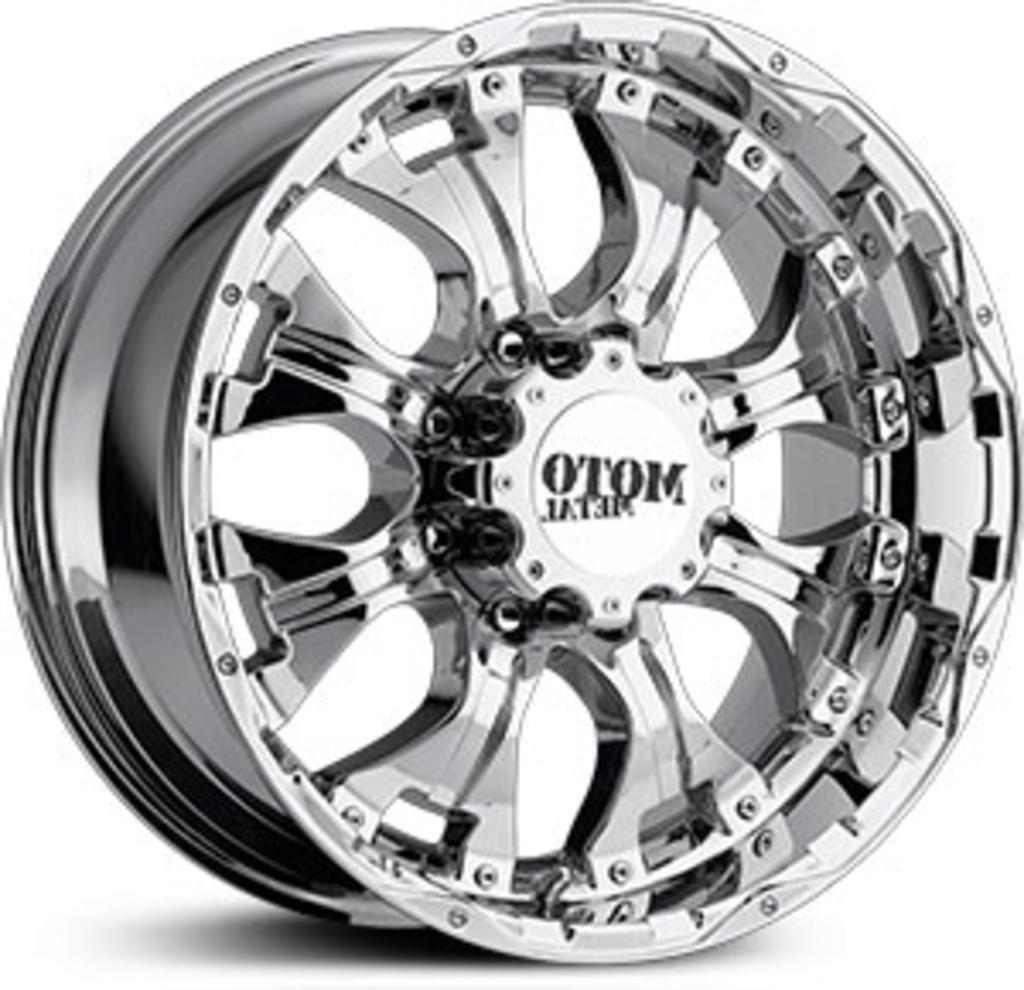What is the main subject of the picture? The main subject of the picture is a rim. What can be seen in the middle of the rim? The name "Moto metal" is present in the middle of the rim. Can you tell me how many stamps are on the rim in the image? There are no stamps present on the rim in the image. What type of pig can be seen interacting with the rim in the image? There is no pig present in the image, and therefore no such interaction can be observed. 